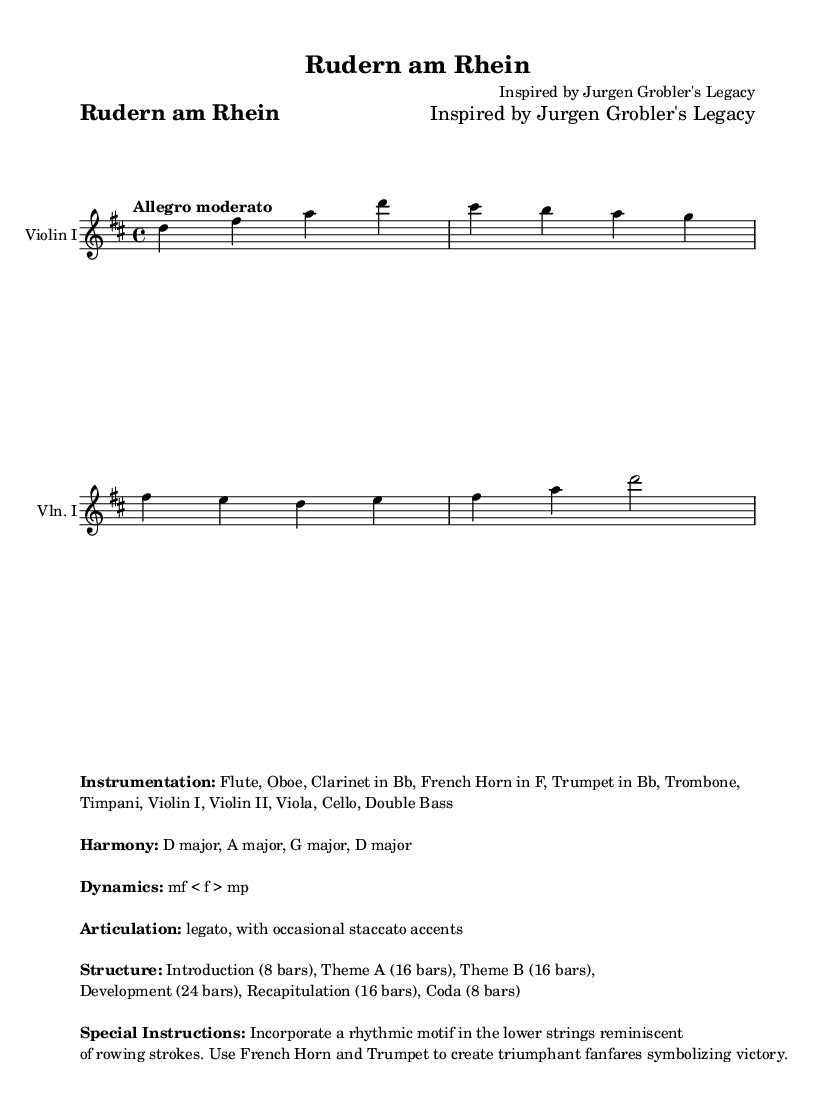What is the title of the composition? The title is indicated in the header of the sheet music, which states "Rudern am Rhein."
Answer: Rudern am Rhein What is the key signature of this music? The key signature is indicated by the global section of the code, where it is defined as D major. D major has two sharps (F# and C#).
Answer: D major What is the time signature for this symphony? The time signature is also defined in the global section of the code, which states that the piece is in 4/4 time.
Answer: 4/4 What tempo is indicated for this piece? The tempo is specified in the global section and is described as "Allegro moderato."
Answer: Allegro moderato How many bars are in the Introduction? The structure provided in the markup section specifies that the Introduction consists of 8 bars.
Answer: 8 bars What instruments are included in the instrumentation? The instrumentation is listed in the markup section and includes Flute, Oboe, Clarinet in Bb, French Horn in F, Trumpet in Bb, Trombone, Timpani, Violin I, Violin II, Viola, Cello, and Double Bass.
Answer: Flute, Oboe, Clarinet in Bb, French Horn in F, Trumpet in Bb, Trombone, Timpani, Violin I, Violin II, Viola, Cello, Double Bass What special instructions are given for this symphony? The special instructions in the markup section state to incorporate a rhythmic motif in the lower strings reminiscent of rowing strokes and to use French Horn and Trumpet to create triumphant fanfares symbolizing victory.
Answer: Incorporate a rhythmic motif in the lower strings reminiscent of rowing strokes. Use French Horn and Trumpet to create triumphant fanfares 